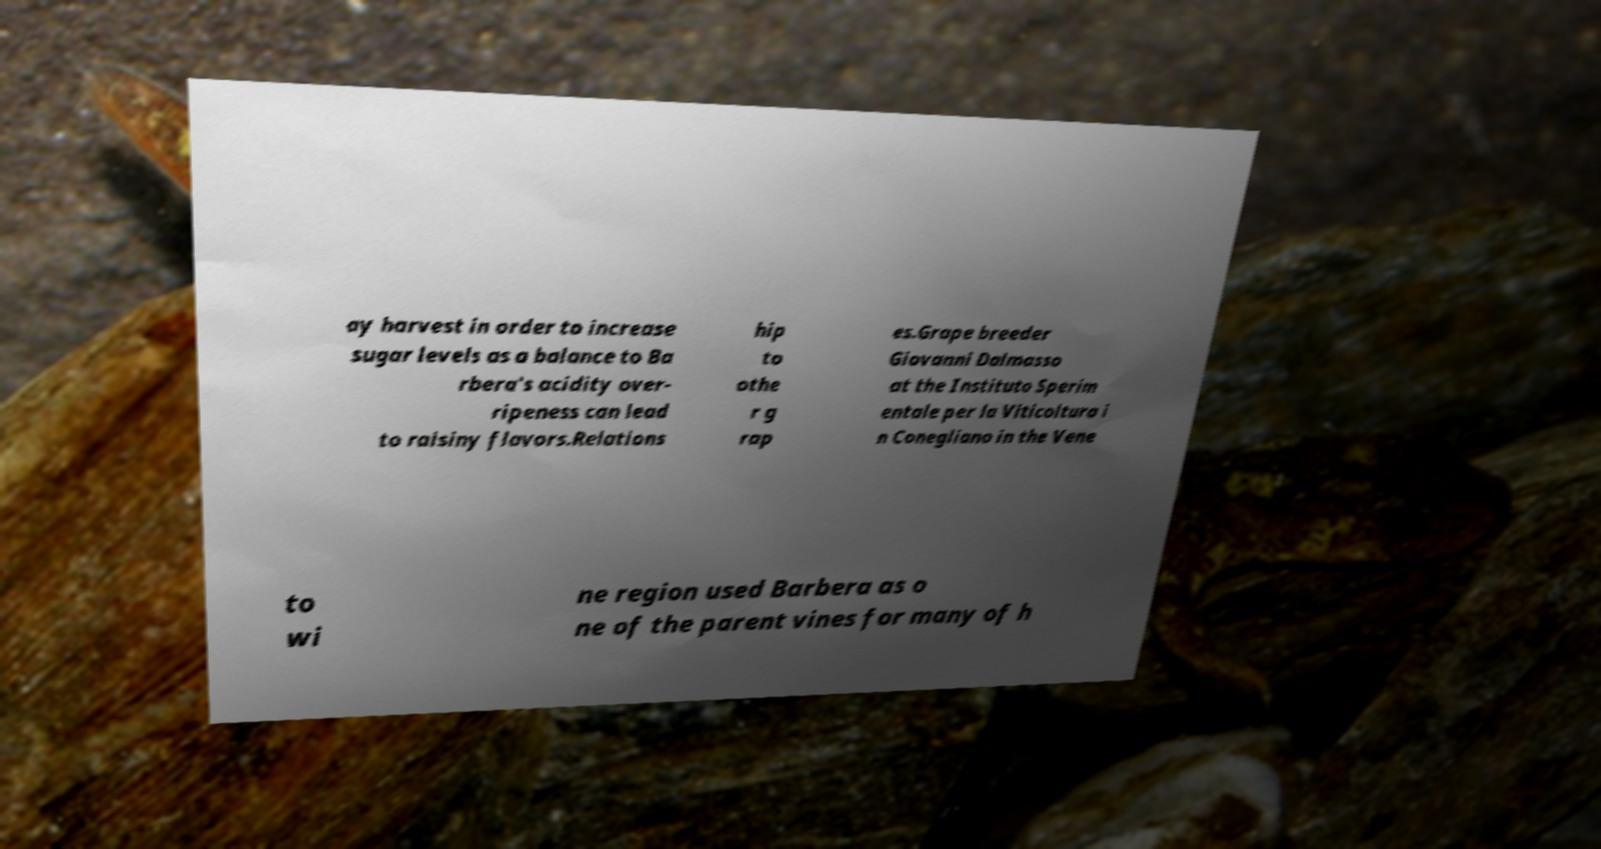Could you extract and type out the text from this image? ay harvest in order to increase sugar levels as a balance to Ba rbera's acidity over- ripeness can lead to raisiny flavors.Relations hip to othe r g rap es.Grape breeder Giovanni Dalmasso at the Instituto Sperim entale per la Viticoltura i n Conegliano in the Vene to wi ne region used Barbera as o ne of the parent vines for many of h 